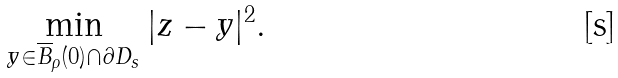<formula> <loc_0><loc_0><loc_500><loc_500>\min _ { y \in \overline { B } _ { \rho } ( 0 ) \cap \partial D _ { s } } | z - y | ^ { 2 } .</formula> 